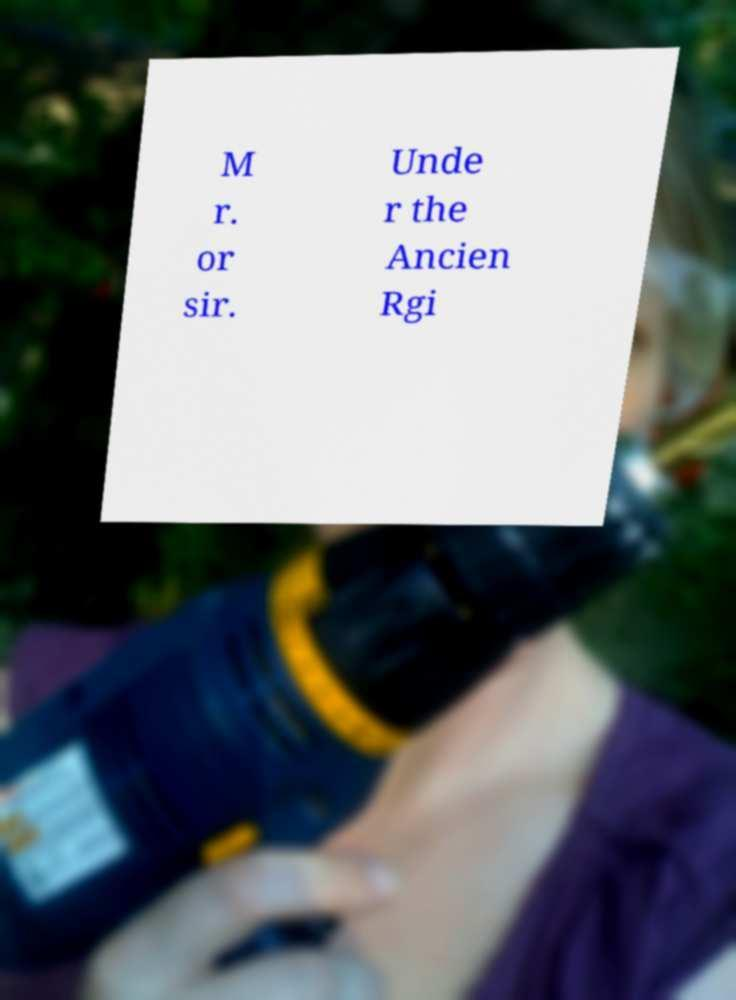What messages or text are displayed in this image? I need them in a readable, typed format. M r. or sir. Unde r the Ancien Rgi 